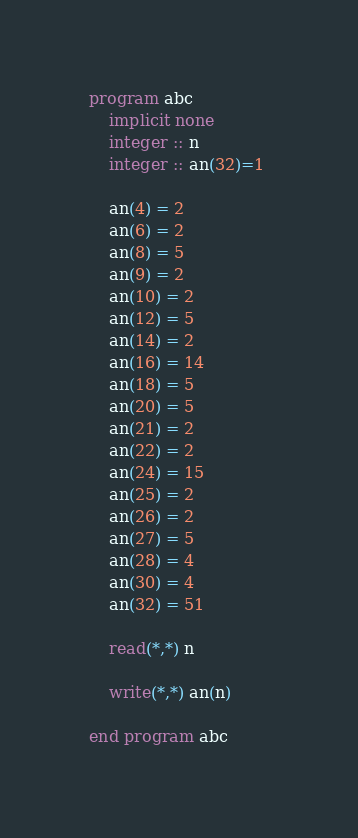Convert code to text. <code><loc_0><loc_0><loc_500><loc_500><_FORTRAN_>program abc
	implicit none
	integer :: n
	integer :: an(32)=1 

	an(4) = 2
    an(6) = 2
    an(8) = 5
    an(9) = 2
    an(10) = 2
    an(12) = 5
    an(14) = 2
    an(16) = 14
    an(18) = 5
    an(20) = 5
    an(21) = 2
	an(22) = 2
    an(24) = 15
    an(25) = 2
    an(26) = 2
    an(27) = 5
    an(28) = 4
    an(30) = 4
    an(32) = 51
    
	read(*,*) n
	
	write(*,*) an(n)
    
end program abc</code> 